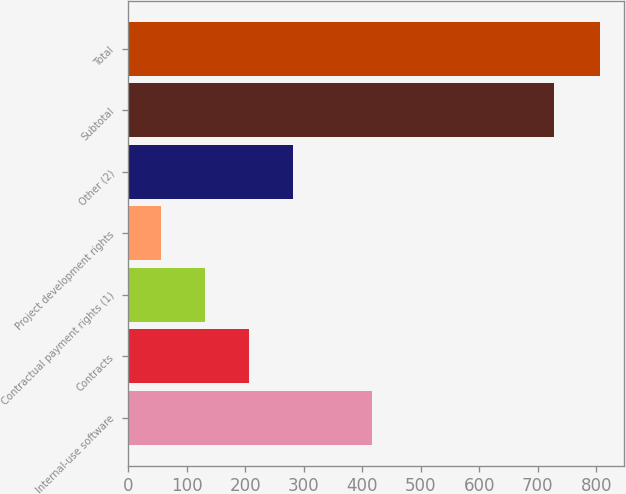Convert chart. <chart><loc_0><loc_0><loc_500><loc_500><bar_chart><fcel>Internal-use software<fcel>Contracts<fcel>Contractual payment rights (1)<fcel>Project development rights<fcel>Other (2)<fcel>Subtotal<fcel>Total<nl><fcel>416<fcel>207<fcel>132<fcel>57<fcel>282<fcel>728<fcel>807<nl></chart> 